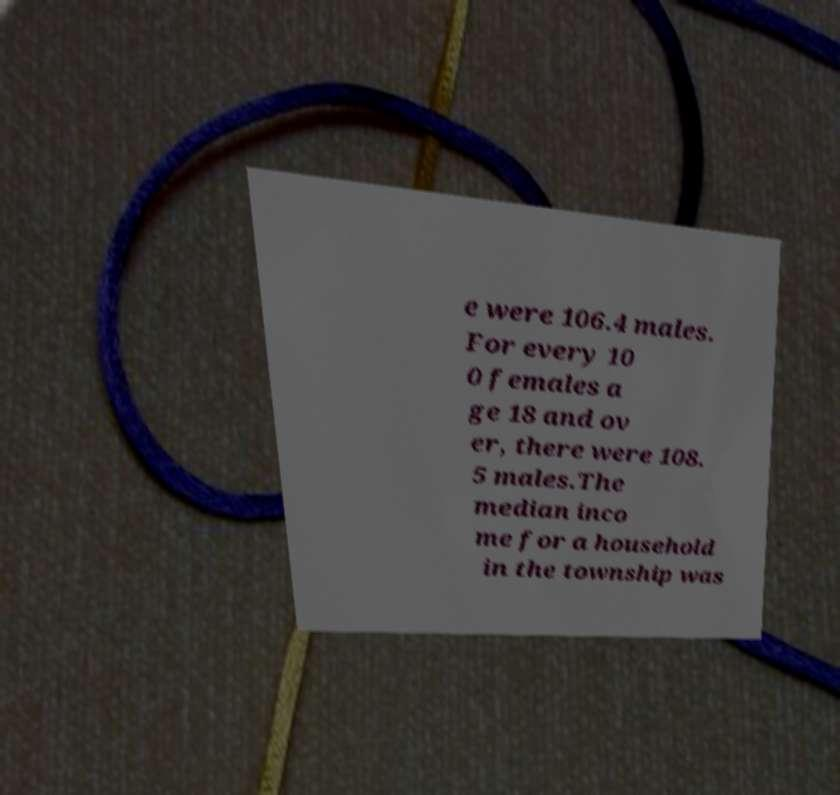There's text embedded in this image that I need extracted. Can you transcribe it verbatim? e were 106.4 males. For every 10 0 females a ge 18 and ov er, there were 108. 5 males.The median inco me for a household in the township was 